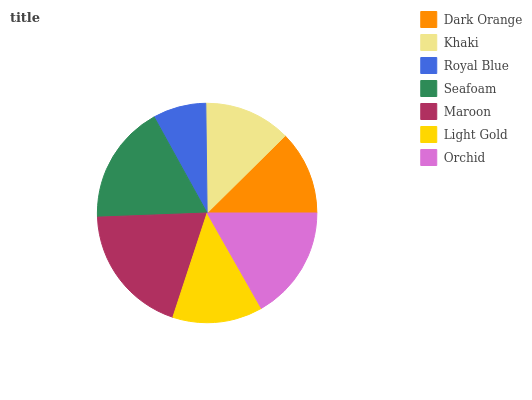Is Royal Blue the minimum?
Answer yes or no. Yes. Is Maroon the maximum?
Answer yes or no. Yes. Is Khaki the minimum?
Answer yes or no. No. Is Khaki the maximum?
Answer yes or no. No. Is Khaki greater than Dark Orange?
Answer yes or no. Yes. Is Dark Orange less than Khaki?
Answer yes or no. Yes. Is Dark Orange greater than Khaki?
Answer yes or no. No. Is Khaki less than Dark Orange?
Answer yes or no. No. Is Light Gold the high median?
Answer yes or no. Yes. Is Light Gold the low median?
Answer yes or no. Yes. Is Maroon the high median?
Answer yes or no. No. Is Seafoam the low median?
Answer yes or no. No. 